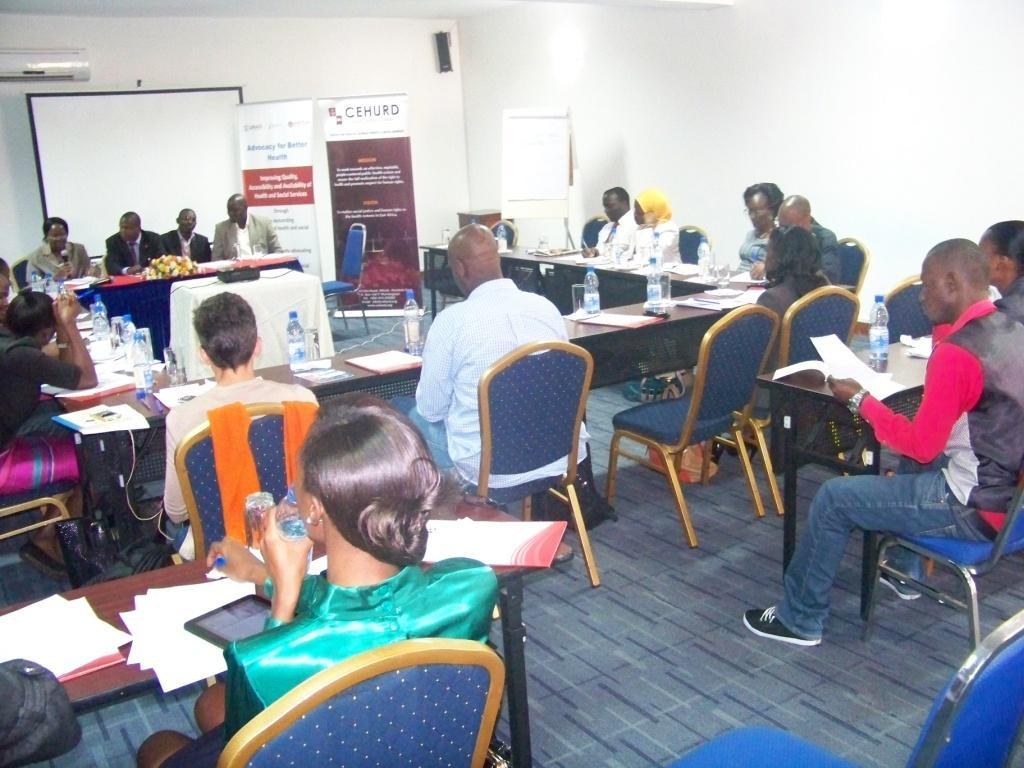Could you give a brief overview of what you see in this image? We can see air conditioner over a wall. We can see banners and boards near to the wall. We can see all the persons sitting on chairs in front of a table and on the table we can see books, bottles. Here we can see four persons sitting near to the to the table. There is a flower bouquet on the table. This is a floor. 